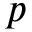<formula> <loc_0><loc_0><loc_500><loc_500>p</formula> 